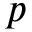<formula> <loc_0><loc_0><loc_500><loc_500>p</formula> 